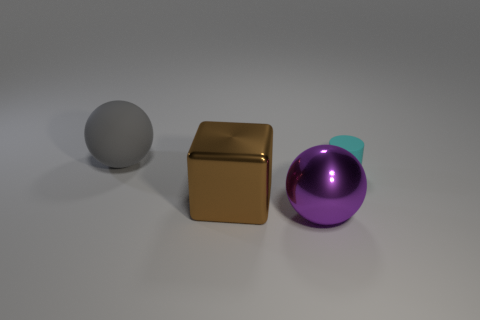Subtract 1 spheres. How many spheres are left? 1 Subtract all yellow cylinders. How many purple balls are left? 1 Subtract all purple spheres. How many spheres are left? 1 Subtract 1 gray spheres. How many objects are left? 3 Subtract all blocks. How many objects are left? 3 Subtract all yellow cylinders. Subtract all purple balls. How many cylinders are left? 1 Subtract all brown shiny things. Subtract all big cyan cubes. How many objects are left? 3 Add 3 metallic cubes. How many metallic cubes are left? 4 Add 1 yellow metallic cubes. How many yellow metallic cubes exist? 1 Add 2 large shiny spheres. How many objects exist? 6 